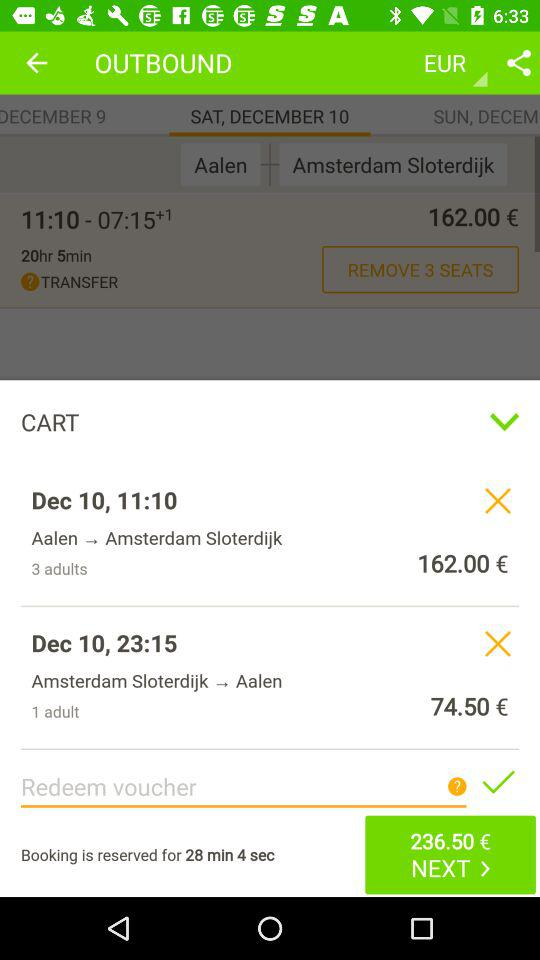What is the time of the reserved booking? The time is 28 minutes and 4 seconds. 